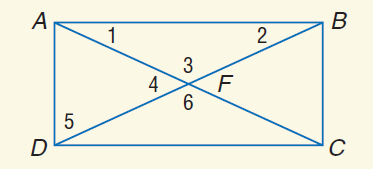Answer the mathemtical geometry problem and directly provide the correct option letter.
Question: A B C D is a rectangle. If A C = 9 x - 1 and A F = 2 x + 7, find A F.
Choices: A: 3 B: 6 C: 13 D: 26 C 